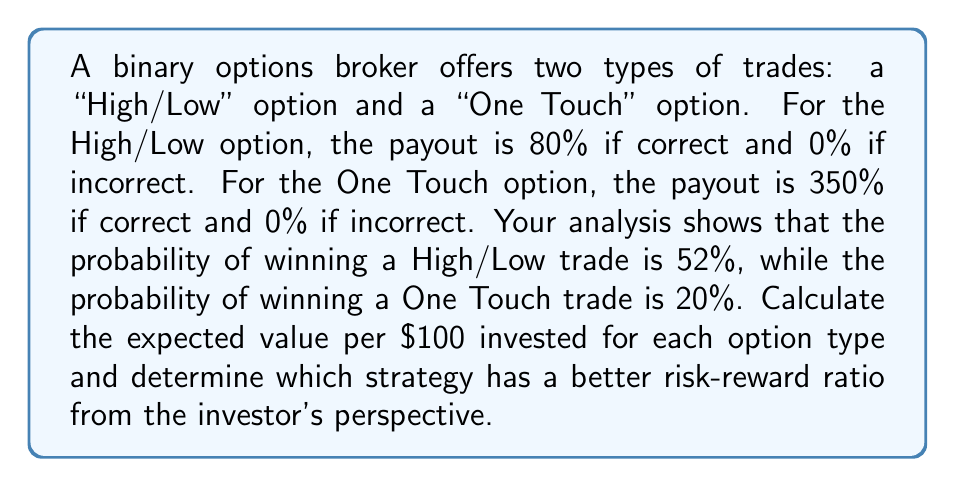Provide a solution to this math problem. To analyze the risk-reward ratio of these binary options strategies using game theory, we need to calculate the expected value (EV) for each option type. The expected value represents the average outcome of an event if it is repeated many times.

1. High/Low Option:
   Let's define the following:
   $p_H$ = probability of winning (52% = 0.52)
   $w_H$ = payout percentage if correct (80% = 0.8)
   $l_H$ = loss percentage if incorrect (100% = 1)

   The expected value formula for High/Low option per $100 invested is:
   $$EV_H = 100 \times (p_H \times w_H - (1-p_H) \times l_H)$$
   $$EV_H = 100 \times (0.52 \times 0.8 - 0.48 \times 1)$$
   $$EV_H = 100 \times (0.416 - 0.48)$$
   $$EV_H = 100 \times (-0.064)$$
   $$EV_H = -$6.40$$

2. One Touch Option:
   Let's define the following:
   $p_O$ = probability of winning (20% = 0.2)
   $w_O$ = payout percentage if correct (350% = 3.5)
   $l_O$ = loss percentage if incorrect (100% = 1)

   The expected value formula for One Touch option per $100 invested is:
   $$EV_O = 100 \times (p_O \times w_O - (1-p_O) \times l_O)$$
   $$EV_O = 100 \times (0.2 \times 3.5 - 0.8 \times 1)$$
   $$EV_O = 100 \times (0.7 - 0.8)$$
   $$EV_O = 100 \times (-0.1)$$
   $$EV_O = -$10.00$$

To determine which strategy has a better risk-reward ratio, we compare the expected values:

The High/Low option has an expected value of -$6.40 per $100 invested.
The One Touch option has an expected value of -$10.00 per $100 invested.

Since both expected values are negative, neither option is favorable for the investor in the long run. However, the High/Low option has a less negative expected value, indicating a better risk-reward ratio from the investor's perspective.
Answer: The High/Low option has a better risk-reward ratio with an expected value of -$6.40 per $100 invested, compared to -$10.00 for the One Touch option. However, both strategies have negative expected values, indicating that neither is profitable for the investor in the long term. 